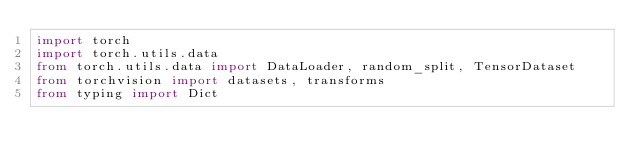Convert code to text. <code><loc_0><loc_0><loc_500><loc_500><_Python_>import torch
import torch.utils.data
from torch.utils.data import DataLoader, random_split, TensorDataset
from torchvision import datasets, transforms
from typing import Dict</code> 